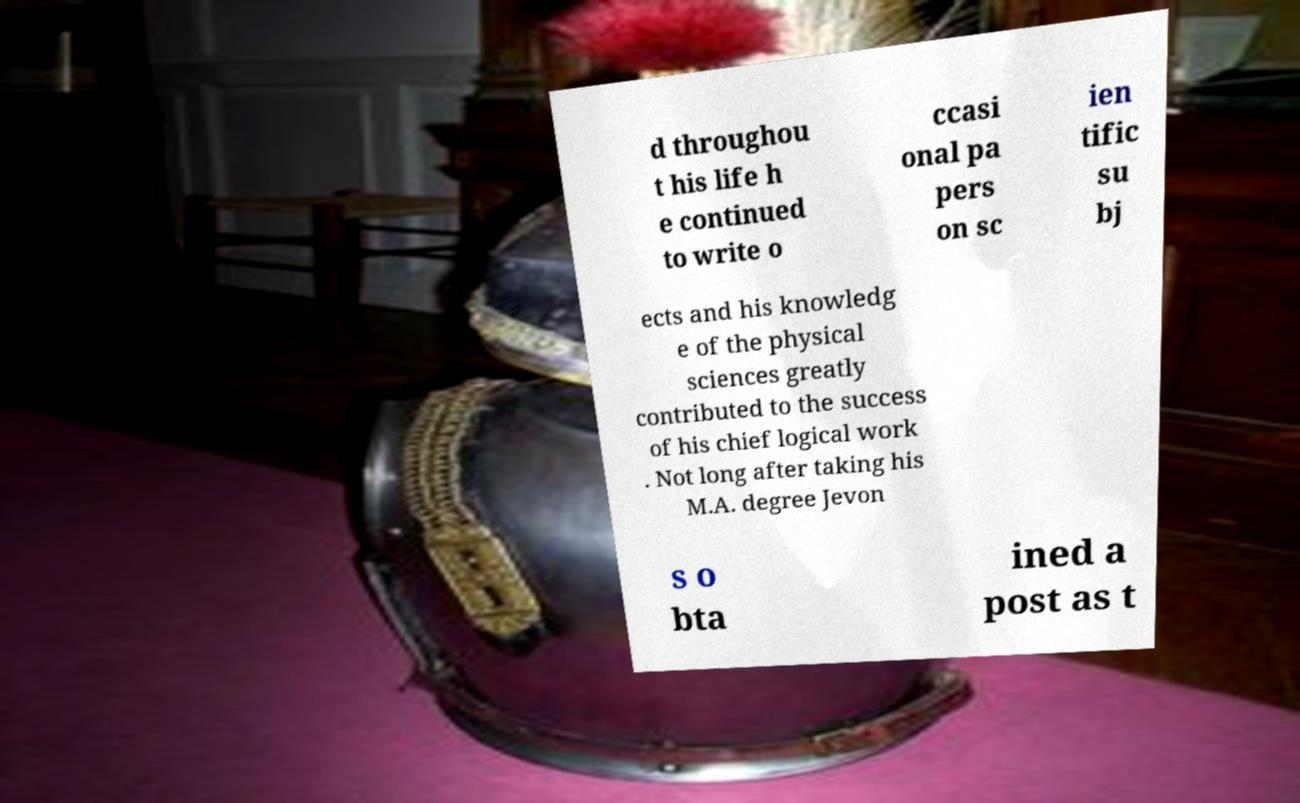Can you read and provide the text displayed in the image?This photo seems to have some interesting text. Can you extract and type it out for me? d throughou t his life h e continued to write o ccasi onal pa pers on sc ien tific su bj ects and his knowledg e of the physical sciences greatly contributed to the success of his chief logical work . Not long after taking his M.A. degree Jevon s o bta ined a post as t 